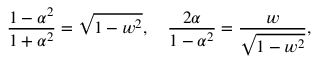<formula> <loc_0><loc_0><loc_500><loc_500>{ \frac { 1 - \alpha ^ { 2 } } { 1 + \alpha ^ { 2 } } } = { \sqrt { 1 - w ^ { 2 } } } , \quad \frac { 2 \alpha } { 1 - \alpha ^ { 2 } } = { \frac { w } { \sqrt { 1 - w ^ { 2 } } } } ,</formula> 